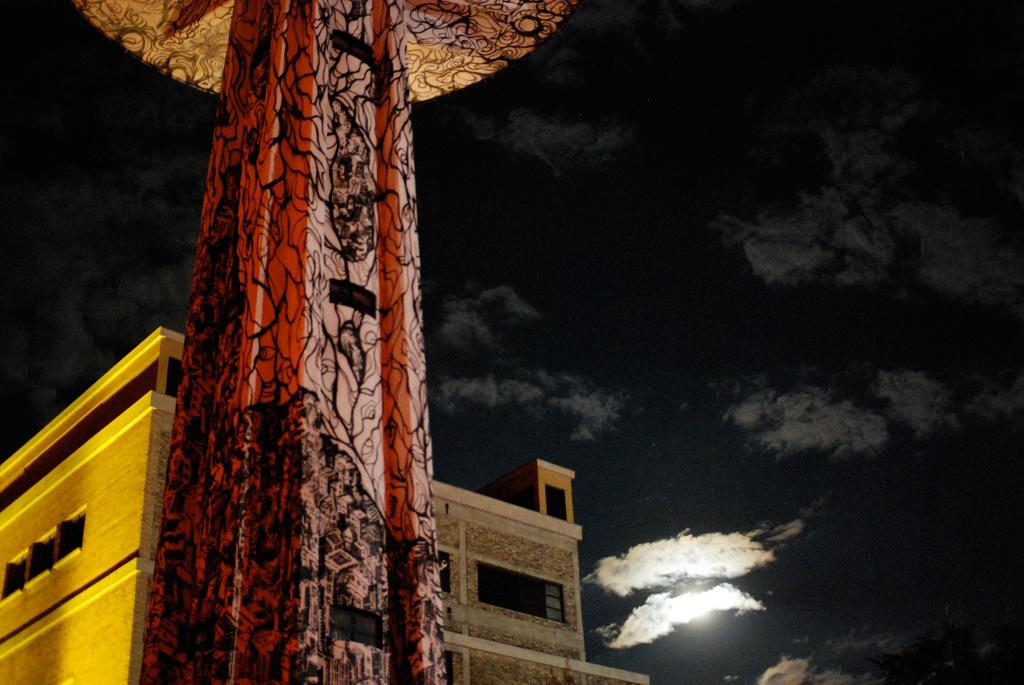What is the main structure visible in the image? There is a pillar in the image. What is located behind the pillar? There is a building behind the pillar. What can be seen in the sky at the top of the image? Clouds are visible in the sky at the top of the image. What type of protest is taking place in front of the pillar in the image? There is no protest present in the image; it only features a pillar, a building, and clouds in the sky. 